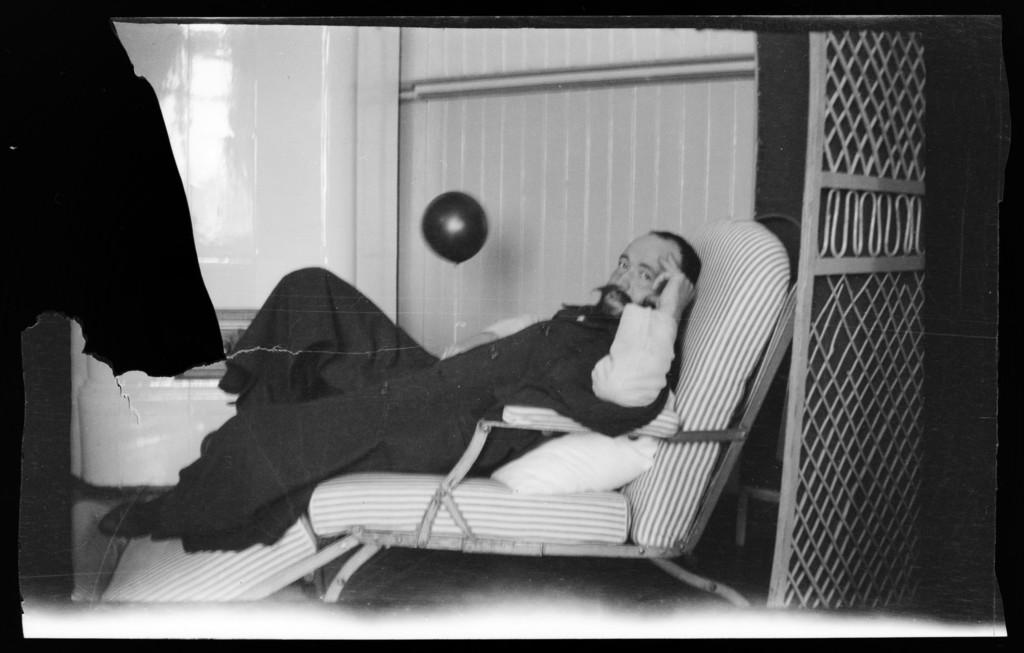Who is present in the image? There is a man in the image. What is the man doing in the image? The man is lying on a chair. What can be seen beneath the man in the image? There is a floor visible in the image. What architectural features can be seen in the background of the image? There is a door and a wall in the background of the image. What is the man wearing in the image? The man is wearing a black and white dress. What type of jam is the man spreading on the riddle in the image? There is no jam or riddle present in the image; the man is lying on a chair wearing a black and white dress. 